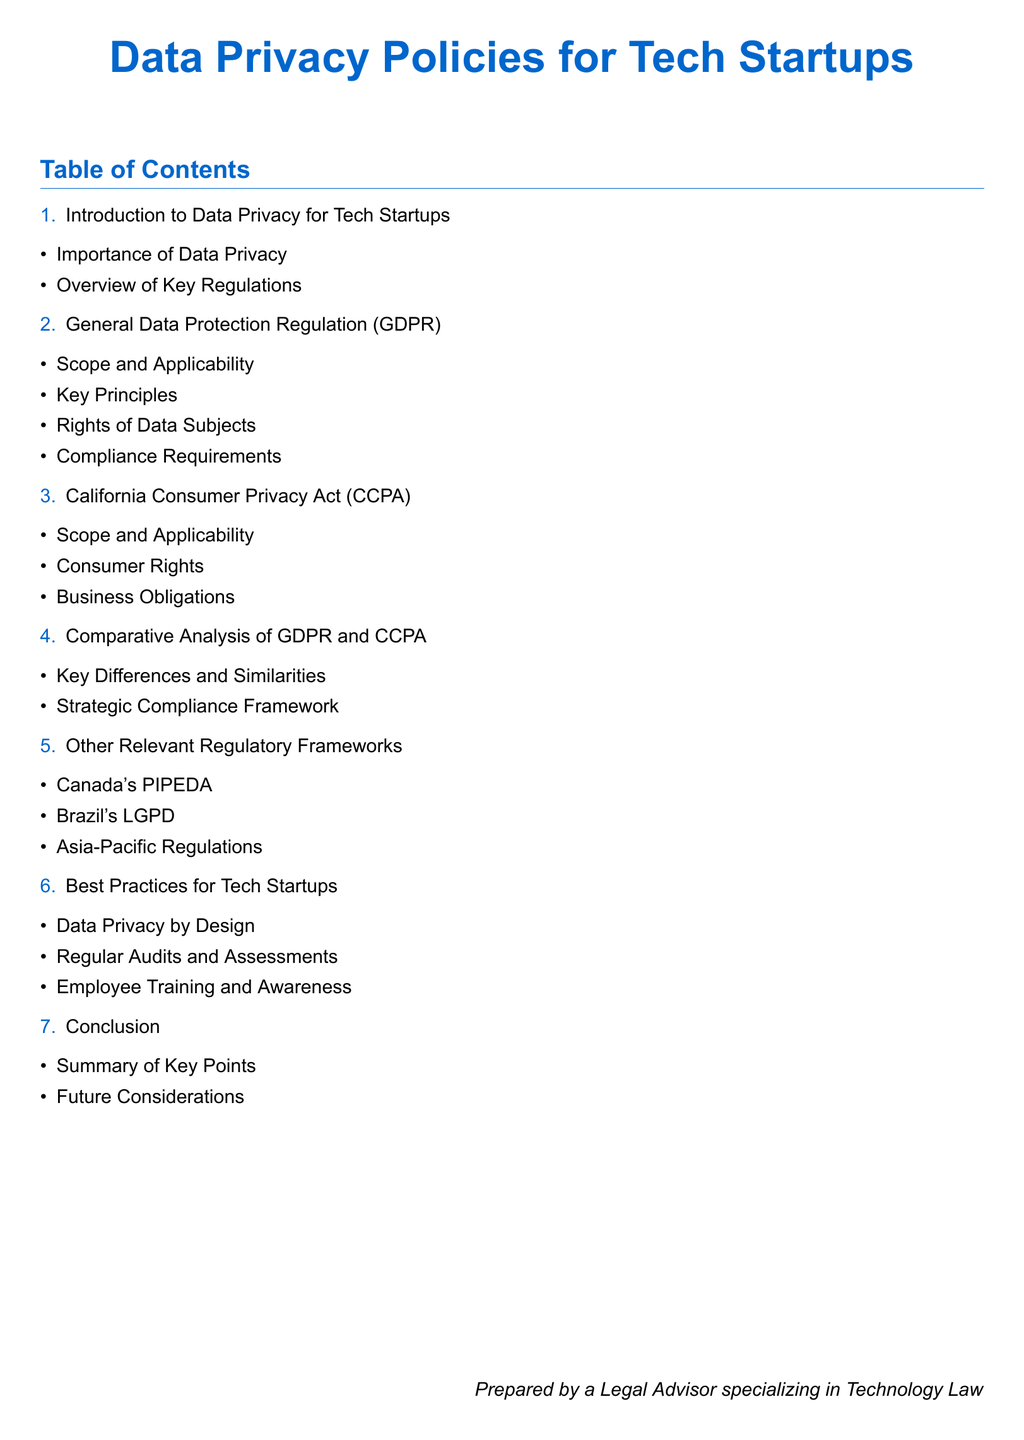What is the title of the document? The title of the document is prominently displayed at the top.
Answer: Data Privacy Policies for Tech Startups What is the first section of the document? The first section appears immediately after the title and focuses on data privacy relevance.
Answer: Introduction to Data Privacy for Tech Startups How many key regulations are overviewed in the document? This number can be found in the second bullet of the first section.
Answer: Two What is the main focus of the comparative analysis section? The section title provides insight into what is compared.
Answer: Key Differences and Similarities Name one of the consumer rights under CCPA. This information is contained within the CCPA's subsection.
Answer: Consumer Rights What is one best practice recommended for tech startups? The best practices section outlines multiple strategies.
Answer: Data Privacy by Design Which regulation is not discussed in the document? The section on other relevant regulatory frameworks highlights various laws, excluding others.
Answer: None What does the conclusion summarize? The last section discusses the overall insights of the previous content.
Answer: Key Points How many items are listed under the GDPR section? The GDPR section includes items listed under it, which provide a count.
Answer: Four 